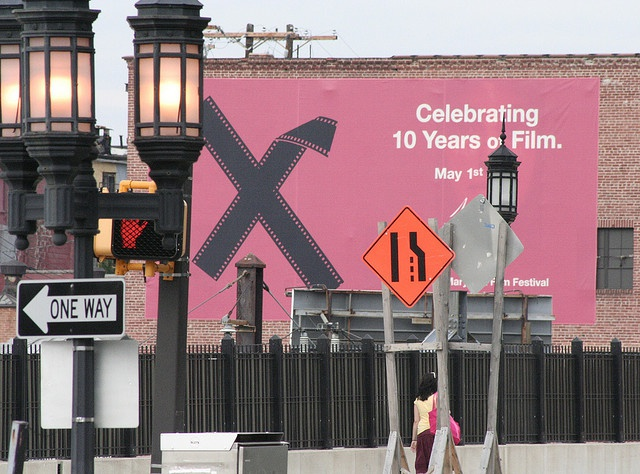Describe the objects in this image and their specific colors. I can see traffic light in gray, black, maroon, and brown tones, people in gray, black, maroon, and tan tones, and handbag in gray, violet, and brown tones in this image. 